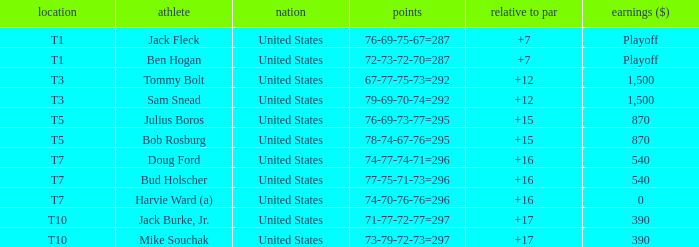What is the total of all to par with player Bob Rosburg? 15.0. 